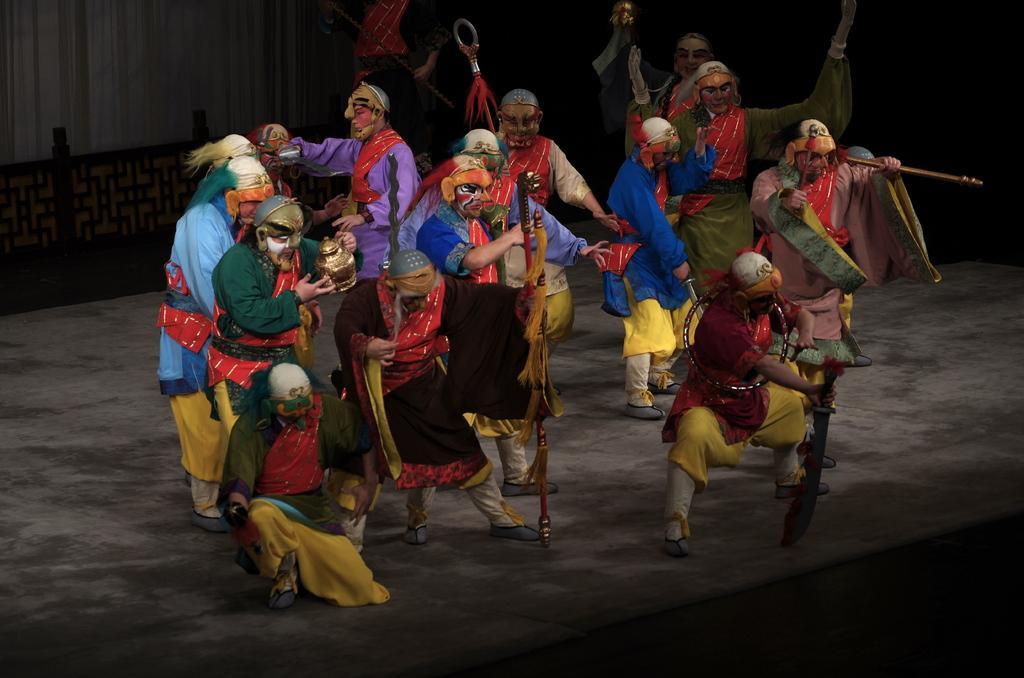Can you describe this image briefly? In this image, I can see a group of people dancing. They wore the fancy dresses. At the bottom of the image, I can see the floor. On the left side of the image, It is looking like a wooden fence. At the top of the image, I can see a person standing and holding an object. 